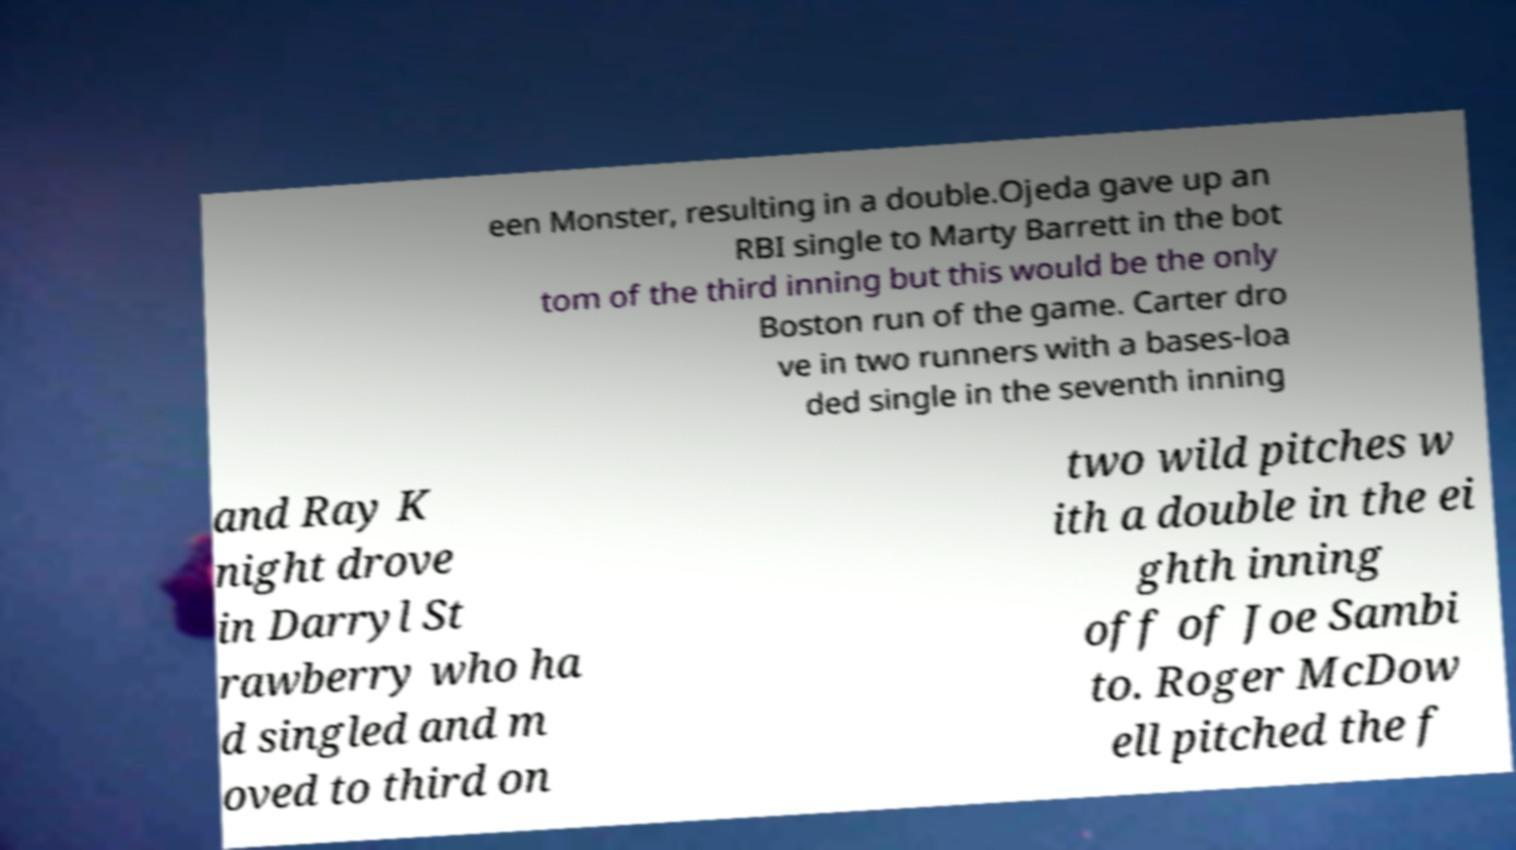Can you read and provide the text displayed in the image?This photo seems to have some interesting text. Can you extract and type it out for me? een Monster, resulting in a double.Ojeda gave up an RBI single to Marty Barrett in the bot tom of the third inning but this would be the only Boston run of the game. Carter dro ve in two runners with a bases-loa ded single in the seventh inning and Ray K night drove in Darryl St rawberry who ha d singled and m oved to third on two wild pitches w ith a double in the ei ghth inning off of Joe Sambi to. Roger McDow ell pitched the f 